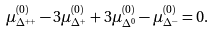<formula> <loc_0><loc_0><loc_500><loc_500>\mu _ { \Delta ^ { + + } } ^ { ( 0 ) } - 3 \mu _ { \Delta ^ { + } } ^ { ( 0 ) } + 3 \mu _ { \Delta ^ { 0 } } ^ { ( 0 ) } - \mu _ { \Delta ^ { - } } ^ { ( 0 ) } = 0 .</formula> 